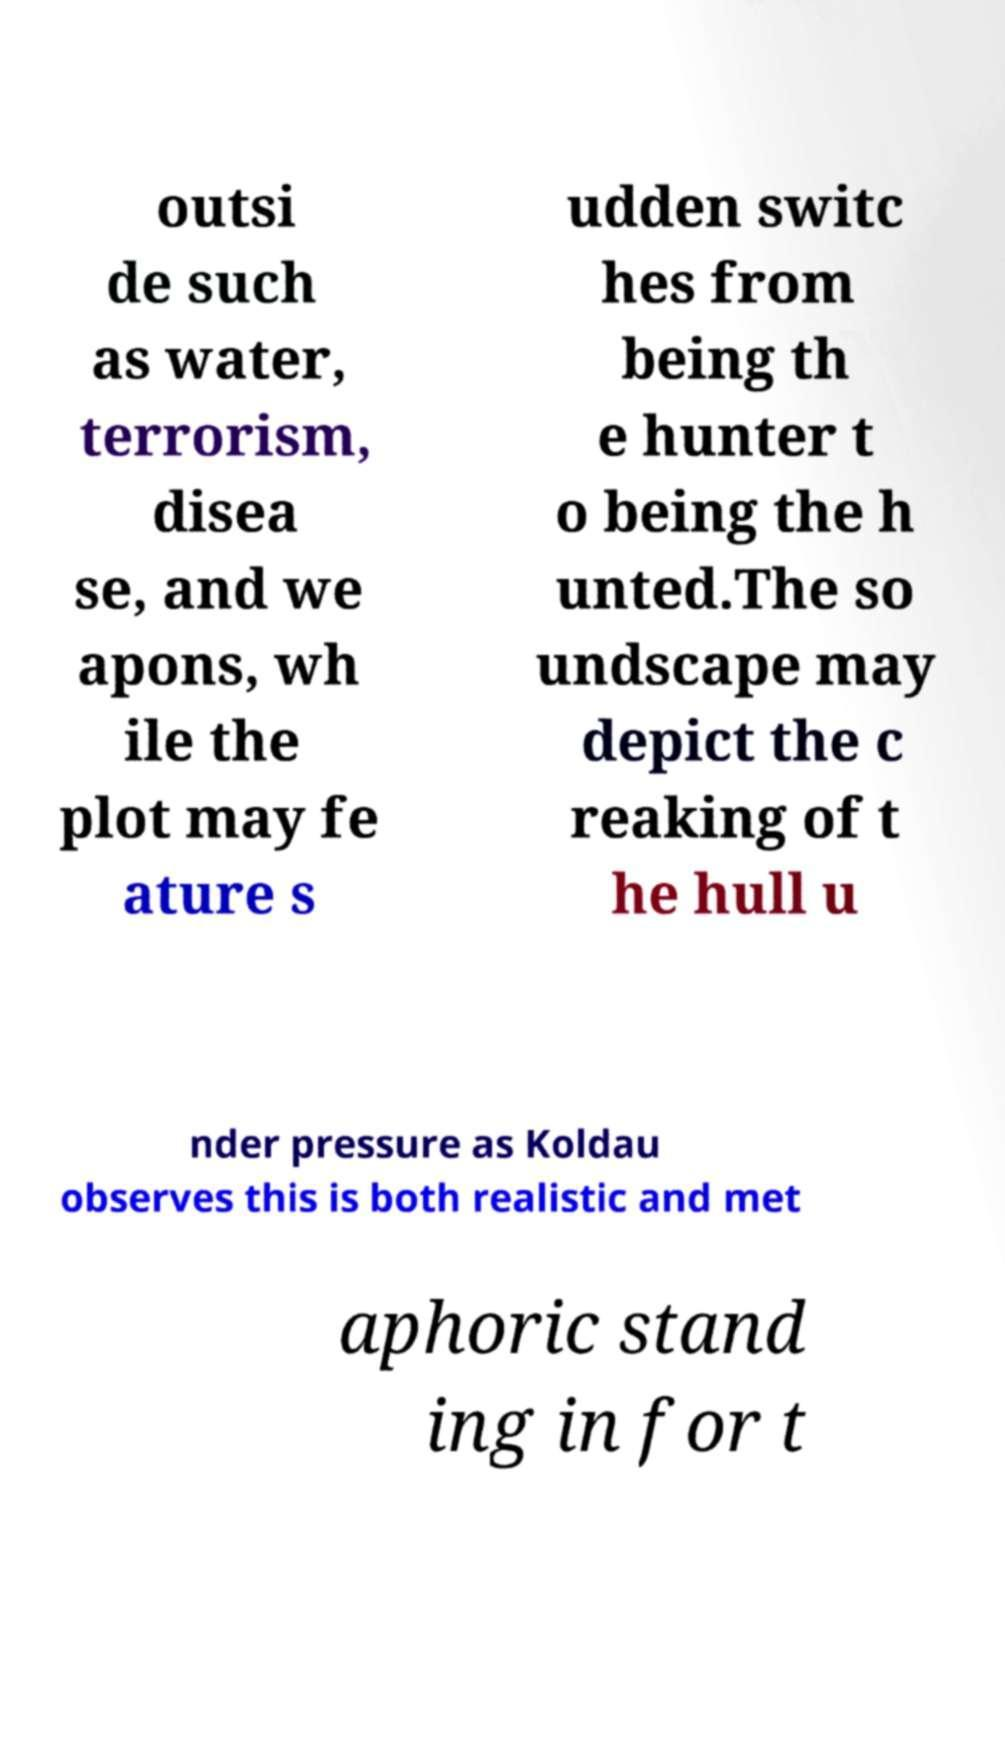I need the written content from this picture converted into text. Can you do that? outsi de such as water, terrorism, disea se, and we apons, wh ile the plot may fe ature s udden switc hes from being th e hunter t o being the h unted.The so undscape may depict the c reaking of t he hull u nder pressure as Koldau observes this is both realistic and met aphoric stand ing in for t 